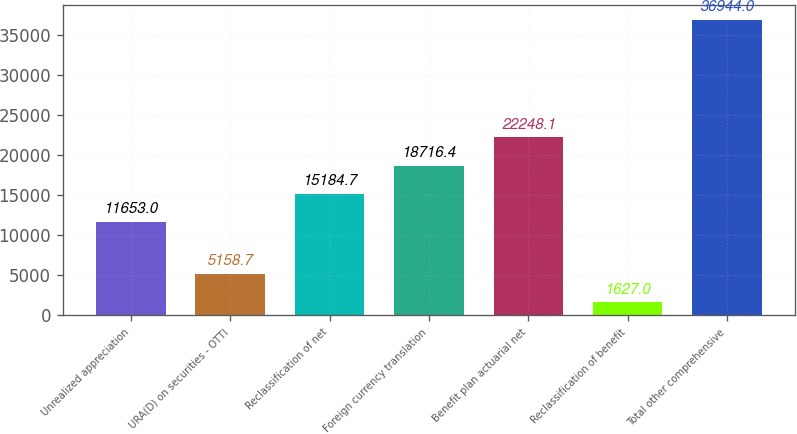Convert chart. <chart><loc_0><loc_0><loc_500><loc_500><bar_chart><fcel>Unrealized appreciation<fcel>URA(D) on securities - OTTI<fcel>Reclassification of net<fcel>Foreign currency translation<fcel>Benefit plan actuarial net<fcel>Reclassification of benefit<fcel>Total other comprehensive<nl><fcel>11653<fcel>5158.7<fcel>15184.7<fcel>18716.4<fcel>22248.1<fcel>1627<fcel>36944<nl></chart> 